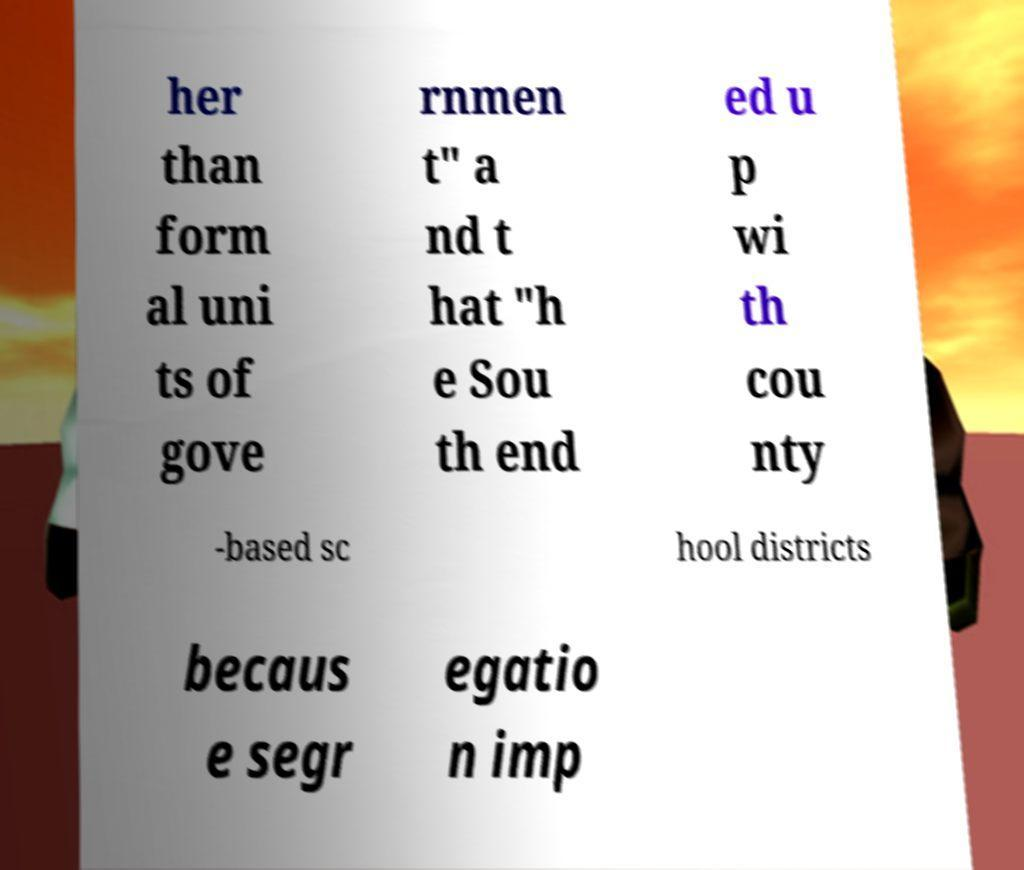Could you extract and type out the text from this image? her than form al uni ts of gove rnmen t" a nd t hat "h e Sou th end ed u p wi th cou nty -based sc hool districts becaus e segr egatio n imp 